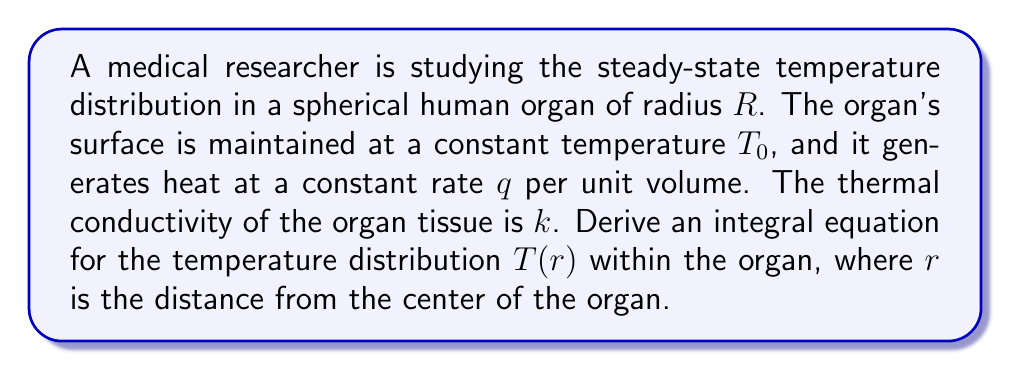Provide a solution to this math problem. Let's approach this problem step-by-step:

1) First, we need to consider the heat equation in spherical coordinates for steady-state conditions:

   $$\frac{1}{r^2}\frac{d}{dr}\left(r^2\frac{dT}{dr}\right) + \frac{q}{k} = 0$$

2) Integrate this equation with respect to r:

   $$\int_0^r \frac{1}{r^2}\frac{d}{dr}\left(r^2\frac{dT}{dr}\right)dr + \int_0^r \frac{q}{k}dr = 0$$

3) The first integral simplifies to:

   $$\frac{1}{r^2}\left[r^2\frac{dT}{dr}\right]_0^r + \frac{qr}{k} = 0$$

4) Assuming the temperature gradient at the center (r = 0) is finite, we get:

   $$\frac{dT}{dr} + \frac{qr}{3k} = 0$$

5) Integrate this equation again from r to R:

   $$\int_r^R \frac{dT}{dr}dr + \int_r^R \frac{qr}{3k}dr = 0$$

6) Simplify:

   $$T(R) - T(r) + \frac{q}{6k}(R^2 - r^2) = 0$$

7) Since T(R) = T₀ (boundary condition), we can rearrange to get:

   $$T(r) = T₀ + \frac{q}{6k}(R^2 - r^2)$$

8) This is the integral equation for the temperature distribution within the organ.
Answer: $$T(r) = T₀ + \frac{q}{6k}(R^2 - r^2)$$ 